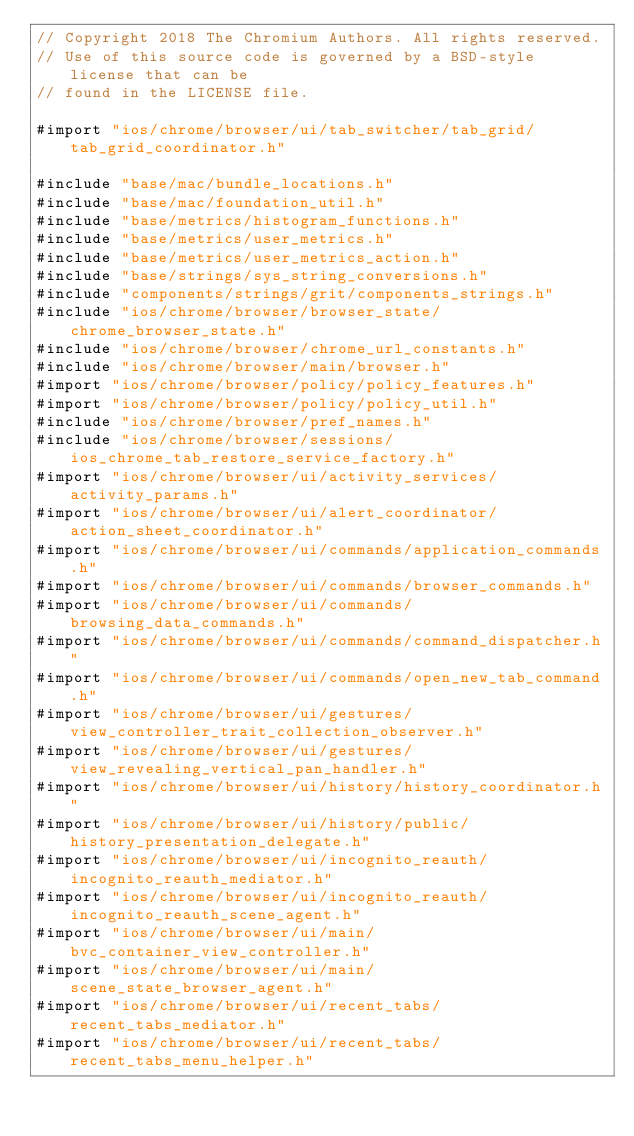<code> <loc_0><loc_0><loc_500><loc_500><_ObjectiveC_>// Copyright 2018 The Chromium Authors. All rights reserved.
// Use of this source code is governed by a BSD-style license that can be
// found in the LICENSE file.

#import "ios/chrome/browser/ui/tab_switcher/tab_grid/tab_grid_coordinator.h"

#include "base/mac/bundle_locations.h"
#include "base/mac/foundation_util.h"
#include "base/metrics/histogram_functions.h"
#include "base/metrics/user_metrics.h"
#include "base/metrics/user_metrics_action.h"
#include "base/strings/sys_string_conversions.h"
#include "components/strings/grit/components_strings.h"
#include "ios/chrome/browser/browser_state/chrome_browser_state.h"
#include "ios/chrome/browser/chrome_url_constants.h"
#include "ios/chrome/browser/main/browser.h"
#import "ios/chrome/browser/policy/policy_features.h"
#import "ios/chrome/browser/policy/policy_util.h"
#include "ios/chrome/browser/pref_names.h"
#include "ios/chrome/browser/sessions/ios_chrome_tab_restore_service_factory.h"
#import "ios/chrome/browser/ui/activity_services/activity_params.h"
#import "ios/chrome/browser/ui/alert_coordinator/action_sheet_coordinator.h"
#import "ios/chrome/browser/ui/commands/application_commands.h"
#import "ios/chrome/browser/ui/commands/browser_commands.h"
#import "ios/chrome/browser/ui/commands/browsing_data_commands.h"
#import "ios/chrome/browser/ui/commands/command_dispatcher.h"
#import "ios/chrome/browser/ui/commands/open_new_tab_command.h"
#import "ios/chrome/browser/ui/gestures/view_controller_trait_collection_observer.h"
#import "ios/chrome/browser/ui/gestures/view_revealing_vertical_pan_handler.h"
#import "ios/chrome/browser/ui/history/history_coordinator.h"
#import "ios/chrome/browser/ui/history/public/history_presentation_delegate.h"
#import "ios/chrome/browser/ui/incognito_reauth/incognito_reauth_mediator.h"
#import "ios/chrome/browser/ui/incognito_reauth/incognito_reauth_scene_agent.h"
#import "ios/chrome/browser/ui/main/bvc_container_view_controller.h"
#import "ios/chrome/browser/ui/main/scene_state_browser_agent.h"
#import "ios/chrome/browser/ui/recent_tabs/recent_tabs_mediator.h"
#import "ios/chrome/browser/ui/recent_tabs/recent_tabs_menu_helper.h"</code> 